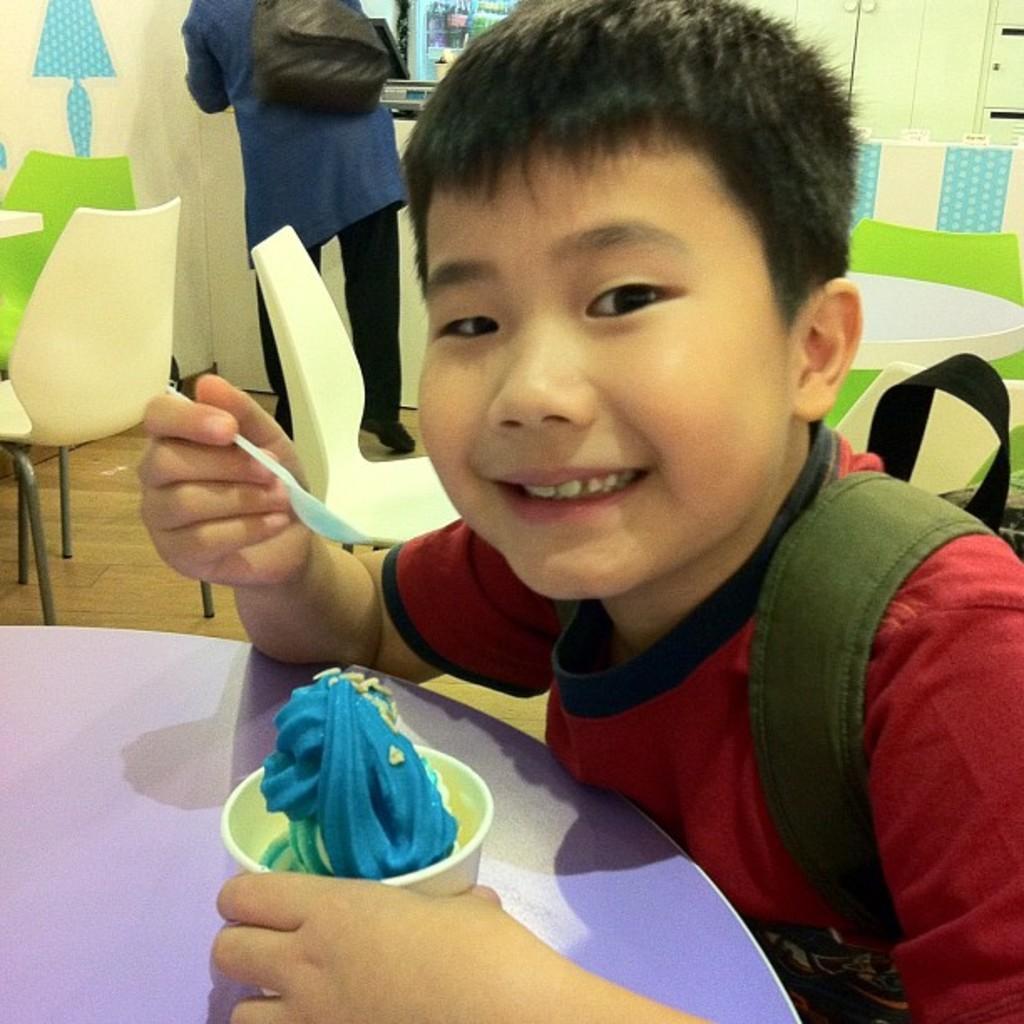Could you give a brief overview of what you see in this image? In this image I can see two persons on the floor, chairs, table and a person is holding an ice cream cup and spoon in hand. In the background I can see a wall, cabinet and so on. This image is taken may be in a restaurant. 